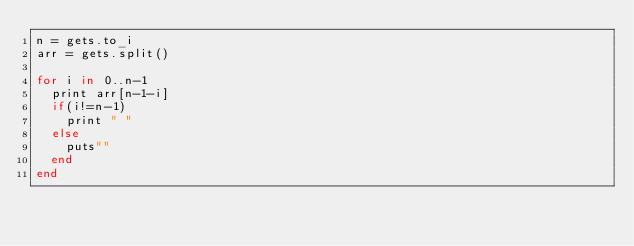Convert code to text. <code><loc_0><loc_0><loc_500><loc_500><_Ruby_>n = gets.to_i
arr = gets.split()

for i in 0..n-1
  print arr[n-1-i]
  if(i!=n-1)
    print " "
  else
    puts""
  end
end</code> 